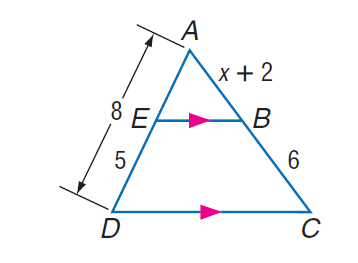Question: Find A B.
Choices:
A. 1.6
B. 2.8
C. 3.6
D. 4
Answer with the letter. Answer: C Question: Find A C.
Choices:
A. 7.6
B. 7.8
C. 9.6
D. 11
Answer with the letter. Answer: C 